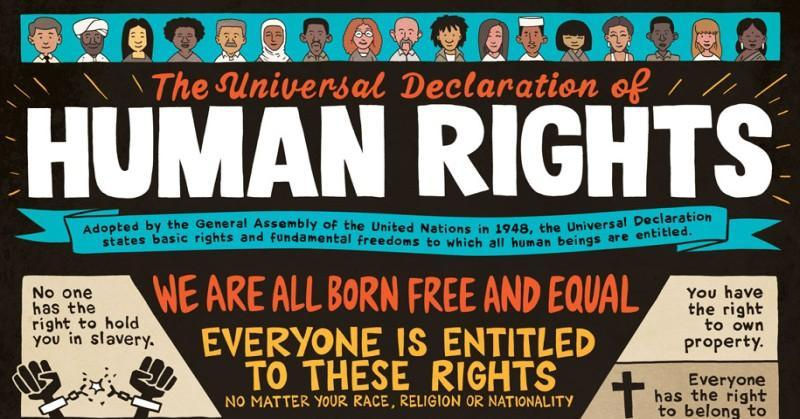What was adopted by the General Assembly of UN in 1948?
Answer the question with a short phrase. The Universal Declaration of Human Rights 